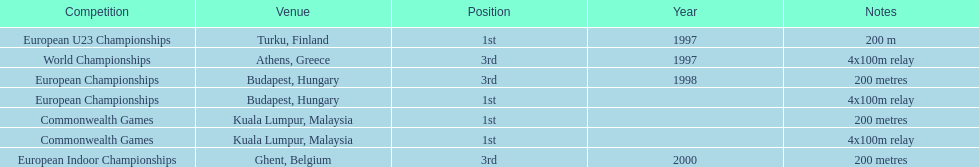In what year did england get the top achievment in the 200 meter? 1997. 